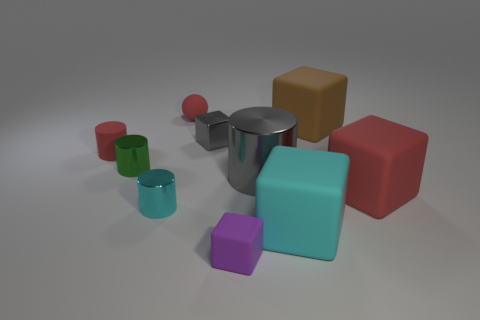Subtract 2 cubes. How many cubes are left? 3 Subtract all cyan cubes. How many cubes are left? 4 Subtract all small matte blocks. How many blocks are left? 4 Subtract all yellow blocks. Subtract all gray cylinders. How many blocks are left? 5 Subtract all cylinders. How many objects are left? 6 Add 3 purple rubber objects. How many purple rubber objects are left? 4 Add 3 purple cubes. How many purple cubes exist? 4 Subtract 1 gray cubes. How many objects are left? 9 Subtract all tiny cyan objects. Subtract all large cyan blocks. How many objects are left? 8 